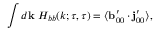<formula> <loc_0><loc_0><loc_500><loc_500>\int d { k } \ H _ { b b } ( k ; \tau , \tau ) = \langle { { b } _ { 0 0 } ^ { \prime } \cdot { j } _ { 0 0 } ^ { \prime } } \rangle ,</formula> 